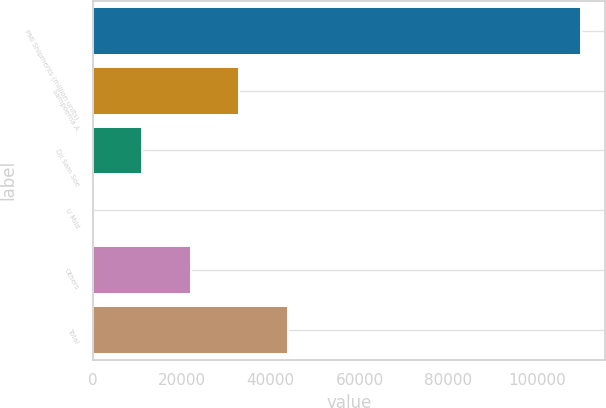Convert chart. <chart><loc_0><loc_0><loc_500><loc_500><bar_chart><fcel>PMI Shipments (million units)<fcel>Sampoerna A<fcel>Dji Sam Soe<fcel>U Mild<fcel>Others<fcel>Total<nl><fcel>109840<fcel>32955.4<fcel>10988.3<fcel>4.8<fcel>21971.8<fcel>43938.9<nl></chart> 